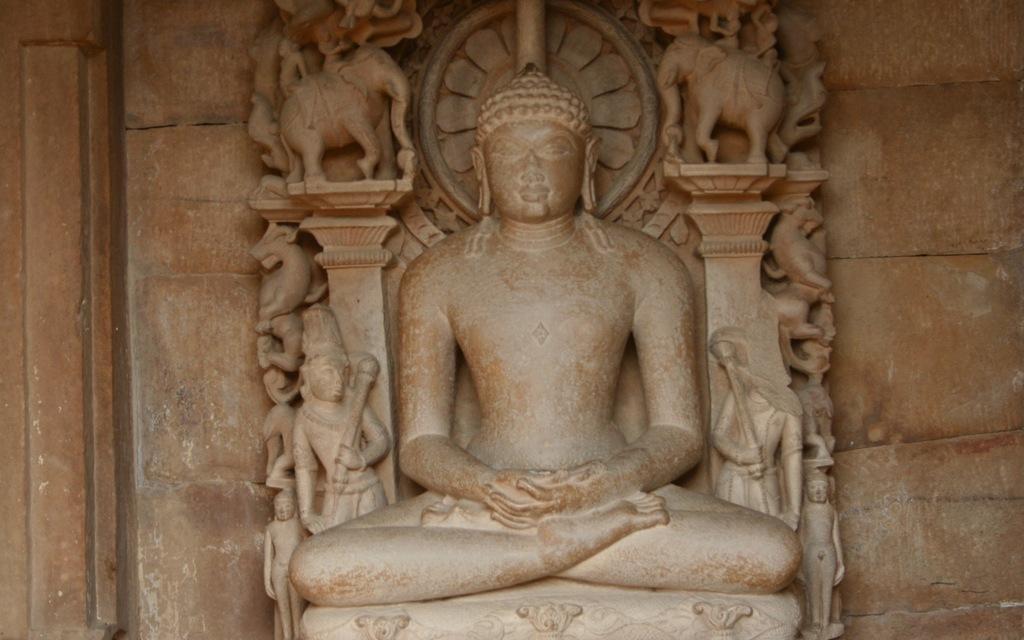Describe this image in one or two sentences. In the image we can see there are sculptures and the wall. 